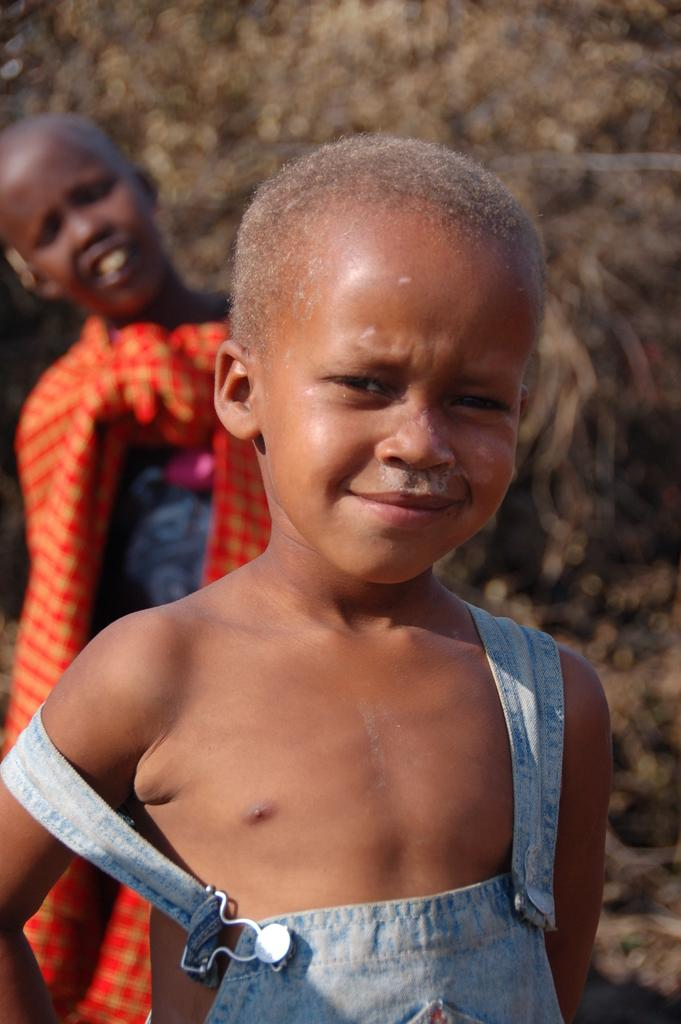What is the main subject of the picture? The main subject of the picture is a small child. Can you describe the child's appearance? The child has a bald head. Is there anyone else in the picture besides the child? Yes, there is another person standing behind the child. What type of button is the child holding in the picture? There is no button present in the picture; the child has a bald head and is accompanied by another person. Can you tell me how many bananas the child is holding in the picture? There are no bananas present in the picture; the child has a bald head and is accompanied by another person. 